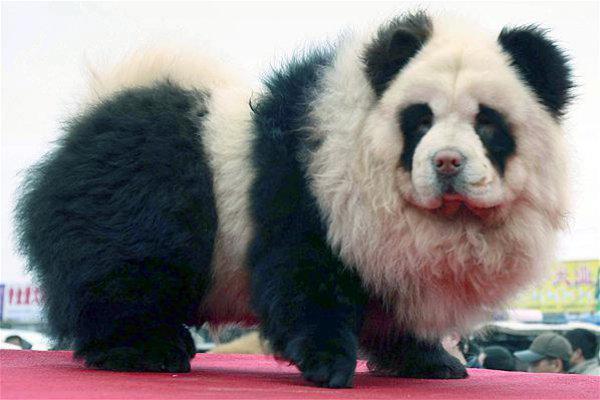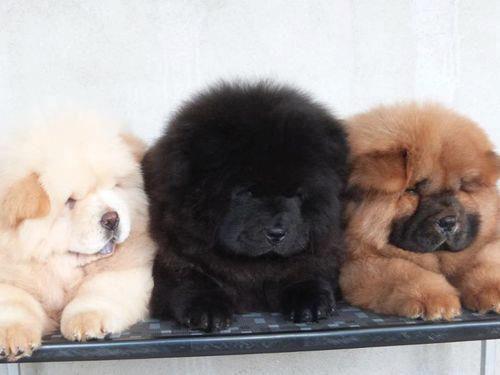The first image is the image on the left, the second image is the image on the right. Analyze the images presented: Is the assertion "There are more chow dogs in the image on the right." valid? Answer yes or no. Yes. 